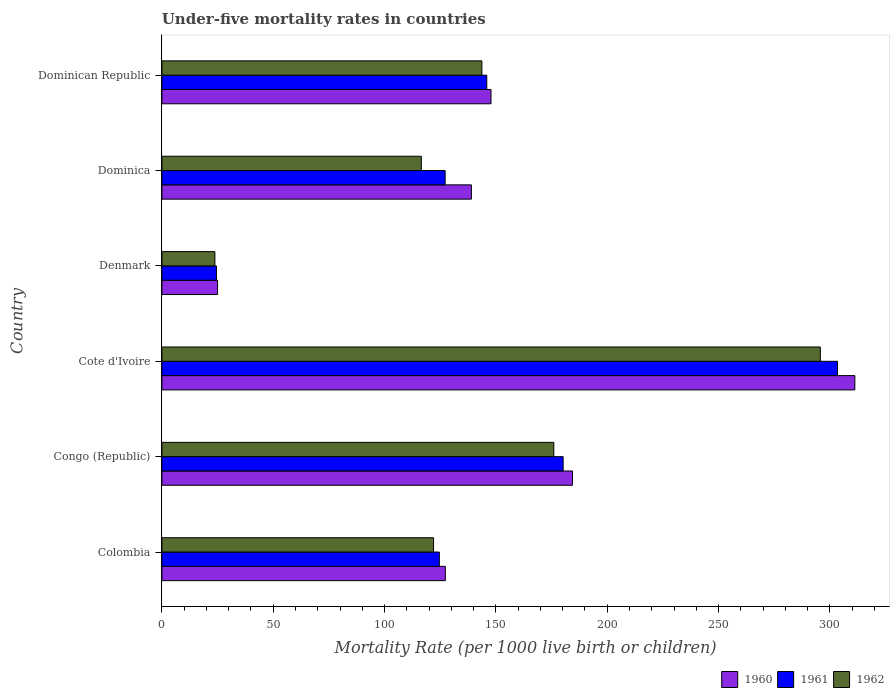How many groups of bars are there?
Your response must be concise. 6. Are the number of bars on each tick of the Y-axis equal?
Your answer should be very brief. Yes. How many bars are there on the 2nd tick from the top?
Offer a terse response. 3. How many bars are there on the 2nd tick from the bottom?
Offer a very short reply. 3. What is the label of the 1st group of bars from the top?
Provide a short and direct response. Dominican Republic. What is the under-five mortality rate in 1962 in Cote d'Ivoire?
Your answer should be very brief. 295.7. Across all countries, what is the maximum under-five mortality rate in 1961?
Give a very brief answer. 303.4. Across all countries, what is the minimum under-five mortality rate in 1960?
Your answer should be compact. 25. In which country was the under-five mortality rate in 1962 maximum?
Your response must be concise. Cote d'Ivoire. In which country was the under-five mortality rate in 1961 minimum?
Your response must be concise. Denmark. What is the total under-five mortality rate in 1962 in the graph?
Make the answer very short. 877.7. What is the difference between the under-five mortality rate in 1960 in Congo (Republic) and that in Dominican Republic?
Offer a very short reply. 36.6. What is the difference between the under-five mortality rate in 1961 in Denmark and the under-five mortality rate in 1960 in Cote d'Ivoire?
Your answer should be compact. -286.7. What is the average under-five mortality rate in 1962 per country?
Keep it short and to the point. 146.28. What is the difference between the under-five mortality rate in 1961 and under-five mortality rate in 1962 in Dominica?
Ensure brevity in your answer.  10.7. In how many countries, is the under-five mortality rate in 1961 greater than 150 ?
Your response must be concise. 2. What is the ratio of the under-five mortality rate in 1961 in Dominica to that in Dominican Republic?
Make the answer very short. 0.87. Is the difference between the under-five mortality rate in 1961 in Cote d'Ivoire and Denmark greater than the difference between the under-five mortality rate in 1962 in Cote d'Ivoire and Denmark?
Provide a succinct answer. Yes. What is the difference between the highest and the second highest under-five mortality rate in 1960?
Give a very brief answer. 126.8. What is the difference between the highest and the lowest under-five mortality rate in 1960?
Give a very brief answer. 286.2. Is the sum of the under-five mortality rate in 1962 in Colombia and Denmark greater than the maximum under-five mortality rate in 1961 across all countries?
Ensure brevity in your answer.  No. How many bars are there?
Give a very brief answer. 18. Are all the bars in the graph horizontal?
Provide a succinct answer. Yes. How many countries are there in the graph?
Your answer should be compact. 6. Does the graph contain any zero values?
Give a very brief answer. No. Does the graph contain grids?
Ensure brevity in your answer.  No. How are the legend labels stacked?
Your response must be concise. Horizontal. What is the title of the graph?
Your answer should be compact. Under-five mortality rates in countries. What is the label or title of the X-axis?
Ensure brevity in your answer.  Mortality Rate (per 1000 live birth or children). What is the Mortality Rate (per 1000 live birth or children) of 1960 in Colombia?
Your answer should be very brief. 127.3. What is the Mortality Rate (per 1000 live birth or children) of 1961 in Colombia?
Keep it short and to the point. 124.6. What is the Mortality Rate (per 1000 live birth or children) in 1962 in Colombia?
Give a very brief answer. 122. What is the Mortality Rate (per 1000 live birth or children) in 1960 in Congo (Republic)?
Your answer should be compact. 184.4. What is the Mortality Rate (per 1000 live birth or children) in 1961 in Congo (Republic)?
Make the answer very short. 180.2. What is the Mortality Rate (per 1000 live birth or children) in 1962 in Congo (Republic)?
Offer a very short reply. 176. What is the Mortality Rate (per 1000 live birth or children) of 1960 in Cote d'Ivoire?
Your answer should be compact. 311.2. What is the Mortality Rate (per 1000 live birth or children) in 1961 in Cote d'Ivoire?
Offer a terse response. 303.4. What is the Mortality Rate (per 1000 live birth or children) in 1962 in Cote d'Ivoire?
Your answer should be very brief. 295.7. What is the Mortality Rate (per 1000 live birth or children) in 1960 in Denmark?
Offer a very short reply. 25. What is the Mortality Rate (per 1000 live birth or children) of 1961 in Denmark?
Your response must be concise. 24.5. What is the Mortality Rate (per 1000 live birth or children) in 1962 in Denmark?
Provide a succinct answer. 23.8. What is the Mortality Rate (per 1000 live birth or children) in 1960 in Dominica?
Provide a succinct answer. 139. What is the Mortality Rate (per 1000 live birth or children) in 1961 in Dominica?
Provide a succinct answer. 127.2. What is the Mortality Rate (per 1000 live birth or children) of 1962 in Dominica?
Your answer should be very brief. 116.5. What is the Mortality Rate (per 1000 live birth or children) of 1960 in Dominican Republic?
Offer a very short reply. 147.8. What is the Mortality Rate (per 1000 live birth or children) of 1961 in Dominican Republic?
Ensure brevity in your answer.  145.9. What is the Mortality Rate (per 1000 live birth or children) of 1962 in Dominican Republic?
Provide a short and direct response. 143.7. Across all countries, what is the maximum Mortality Rate (per 1000 live birth or children) of 1960?
Your answer should be very brief. 311.2. Across all countries, what is the maximum Mortality Rate (per 1000 live birth or children) of 1961?
Ensure brevity in your answer.  303.4. Across all countries, what is the maximum Mortality Rate (per 1000 live birth or children) of 1962?
Your answer should be compact. 295.7. Across all countries, what is the minimum Mortality Rate (per 1000 live birth or children) in 1962?
Offer a terse response. 23.8. What is the total Mortality Rate (per 1000 live birth or children) of 1960 in the graph?
Make the answer very short. 934.7. What is the total Mortality Rate (per 1000 live birth or children) of 1961 in the graph?
Offer a terse response. 905.8. What is the total Mortality Rate (per 1000 live birth or children) in 1962 in the graph?
Make the answer very short. 877.7. What is the difference between the Mortality Rate (per 1000 live birth or children) in 1960 in Colombia and that in Congo (Republic)?
Keep it short and to the point. -57.1. What is the difference between the Mortality Rate (per 1000 live birth or children) in 1961 in Colombia and that in Congo (Republic)?
Make the answer very short. -55.6. What is the difference between the Mortality Rate (per 1000 live birth or children) of 1962 in Colombia and that in Congo (Republic)?
Offer a very short reply. -54. What is the difference between the Mortality Rate (per 1000 live birth or children) in 1960 in Colombia and that in Cote d'Ivoire?
Ensure brevity in your answer.  -183.9. What is the difference between the Mortality Rate (per 1000 live birth or children) in 1961 in Colombia and that in Cote d'Ivoire?
Provide a short and direct response. -178.8. What is the difference between the Mortality Rate (per 1000 live birth or children) of 1962 in Colombia and that in Cote d'Ivoire?
Your answer should be compact. -173.7. What is the difference between the Mortality Rate (per 1000 live birth or children) of 1960 in Colombia and that in Denmark?
Your answer should be very brief. 102.3. What is the difference between the Mortality Rate (per 1000 live birth or children) of 1961 in Colombia and that in Denmark?
Ensure brevity in your answer.  100.1. What is the difference between the Mortality Rate (per 1000 live birth or children) in 1962 in Colombia and that in Denmark?
Your answer should be compact. 98.2. What is the difference between the Mortality Rate (per 1000 live birth or children) in 1962 in Colombia and that in Dominica?
Keep it short and to the point. 5.5. What is the difference between the Mortality Rate (per 1000 live birth or children) in 1960 in Colombia and that in Dominican Republic?
Your answer should be compact. -20.5. What is the difference between the Mortality Rate (per 1000 live birth or children) of 1961 in Colombia and that in Dominican Republic?
Provide a short and direct response. -21.3. What is the difference between the Mortality Rate (per 1000 live birth or children) in 1962 in Colombia and that in Dominican Republic?
Your answer should be compact. -21.7. What is the difference between the Mortality Rate (per 1000 live birth or children) of 1960 in Congo (Republic) and that in Cote d'Ivoire?
Keep it short and to the point. -126.8. What is the difference between the Mortality Rate (per 1000 live birth or children) of 1961 in Congo (Republic) and that in Cote d'Ivoire?
Offer a very short reply. -123.2. What is the difference between the Mortality Rate (per 1000 live birth or children) in 1962 in Congo (Republic) and that in Cote d'Ivoire?
Offer a terse response. -119.7. What is the difference between the Mortality Rate (per 1000 live birth or children) of 1960 in Congo (Republic) and that in Denmark?
Your answer should be very brief. 159.4. What is the difference between the Mortality Rate (per 1000 live birth or children) of 1961 in Congo (Republic) and that in Denmark?
Keep it short and to the point. 155.7. What is the difference between the Mortality Rate (per 1000 live birth or children) of 1962 in Congo (Republic) and that in Denmark?
Make the answer very short. 152.2. What is the difference between the Mortality Rate (per 1000 live birth or children) in 1960 in Congo (Republic) and that in Dominica?
Your answer should be compact. 45.4. What is the difference between the Mortality Rate (per 1000 live birth or children) in 1961 in Congo (Republic) and that in Dominica?
Give a very brief answer. 53. What is the difference between the Mortality Rate (per 1000 live birth or children) in 1962 in Congo (Republic) and that in Dominica?
Your answer should be very brief. 59.5. What is the difference between the Mortality Rate (per 1000 live birth or children) in 1960 in Congo (Republic) and that in Dominican Republic?
Your answer should be very brief. 36.6. What is the difference between the Mortality Rate (per 1000 live birth or children) of 1961 in Congo (Republic) and that in Dominican Republic?
Keep it short and to the point. 34.3. What is the difference between the Mortality Rate (per 1000 live birth or children) in 1962 in Congo (Republic) and that in Dominican Republic?
Make the answer very short. 32.3. What is the difference between the Mortality Rate (per 1000 live birth or children) of 1960 in Cote d'Ivoire and that in Denmark?
Provide a succinct answer. 286.2. What is the difference between the Mortality Rate (per 1000 live birth or children) in 1961 in Cote d'Ivoire and that in Denmark?
Offer a terse response. 278.9. What is the difference between the Mortality Rate (per 1000 live birth or children) in 1962 in Cote d'Ivoire and that in Denmark?
Keep it short and to the point. 271.9. What is the difference between the Mortality Rate (per 1000 live birth or children) of 1960 in Cote d'Ivoire and that in Dominica?
Offer a very short reply. 172.2. What is the difference between the Mortality Rate (per 1000 live birth or children) in 1961 in Cote d'Ivoire and that in Dominica?
Give a very brief answer. 176.2. What is the difference between the Mortality Rate (per 1000 live birth or children) of 1962 in Cote d'Ivoire and that in Dominica?
Provide a short and direct response. 179.2. What is the difference between the Mortality Rate (per 1000 live birth or children) in 1960 in Cote d'Ivoire and that in Dominican Republic?
Offer a very short reply. 163.4. What is the difference between the Mortality Rate (per 1000 live birth or children) of 1961 in Cote d'Ivoire and that in Dominican Republic?
Your answer should be very brief. 157.5. What is the difference between the Mortality Rate (per 1000 live birth or children) of 1962 in Cote d'Ivoire and that in Dominican Republic?
Offer a terse response. 152. What is the difference between the Mortality Rate (per 1000 live birth or children) in 1960 in Denmark and that in Dominica?
Ensure brevity in your answer.  -114. What is the difference between the Mortality Rate (per 1000 live birth or children) in 1961 in Denmark and that in Dominica?
Ensure brevity in your answer.  -102.7. What is the difference between the Mortality Rate (per 1000 live birth or children) of 1962 in Denmark and that in Dominica?
Offer a terse response. -92.7. What is the difference between the Mortality Rate (per 1000 live birth or children) of 1960 in Denmark and that in Dominican Republic?
Offer a very short reply. -122.8. What is the difference between the Mortality Rate (per 1000 live birth or children) of 1961 in Denmark and that in Dominican Republic?
Keep it short and to the point. -121.4. What is the difference between the Mortality Rate (per 1000 live birth or children) of 1962 in Denmark and that in Dominican Republic?
Keep it short and to the point. -119.9. What is the difference between the Mortality Rate (per 1000 live birth or children) of 1961 in Dominica and that in Dominican Republic?
Give a very brief answer. -18.7. What is the difference between the Mortality Rate (per 1000 live birth or children) in 1962 in Dominica and that in Dominican Republic?
Your response must be concise. -27.2. What is the difference between the Mortality Rate (per 1000 live birth or children) of 1960 in Colombia and the Mortality Rate (per 1000 live birth or children) of 1961 in Congo (Republic)?
Make the answer very short. -52.9. What is the difference between the Mortality Rate (per 1000 live birth or children) of 1960 in Colombia and the Mortality Rate (per 1000 live birth or children) of 1962 in Congo (Republic)?
Make the answer very short. -48.7. What is the difference between the Mortality Rate (per 1000 live birth or children) of 1961 in Colombia and the Mortality Rate (per 1000 live birth or children) of 1962 in Congo (Republic)?
Provide a short and direct response. -51.4. What is the difference between the Mortality Rate (per 1000 live birth or children) in 1960 in Colombia and the Mortality Rate (per 1000 live birth or children) in 1961 in Cote d'Ivoire?
Keep it short and to the point. -176.1. What is the difference between the Mortality Rate (per 1000 live birth or children) in 1960 in Colombia and the Mortality Rate (per 1000 live birth or children) in 1962 in Cote d'Ivoire?
Provide a succinct answer. -168.4. What is the difference between the Mortality Rate (per 1000 live birth or children) in 1961 in Colombia and the Mortality Rate (per 1000 live birth or children) in 1962 in Cote d'Ivoire?
Make the answer very short. -171.1. What is the difference between the Mortality Rate (per 1000 live birth or children) of 1960 in Colombia and the Mortality Rate (per 1000 live birth or children) of 1961 in Denmark?
Ensure brevity in your answer.  102.8. What is the difference between the Mortality Rate (per 1000 live birth or children) in 1960 in Colombia and the Mortality Rate (per 1000 live birth or children) in 1962 in Denmark?
Keep it short and to the point. 103.5. What is the difference between the Mortality Rate (per 1000 live birth or children) of 1961 in Colombia and the Mortality Rate (per 1000 live birth or children) of 1962 in Denmark?
Offer a terse response. 100.8. What is the difference between the Mortality Rate (per 1000 live birth or children) in 1960 in Colombia and the Mortality Rate (per 1000 live birth or children) in 1961 in Dominica?
Ensure brevity in your answer.  0.1. What is the difference between the Mortality Rate (per 1000 live birth or children) of 1960 in Colombia and the Mortality Rate (per 1000 live birth or children) of 1962 in Dominica?
Make the answer very short. 10.8. What is the difference between the Mortality Rate (per 1000 live birth or children) of 1960 in Colombia and the Mortality Rate (per 1000 live birth or children) of 1961 in Dominican Republic?
Give a very brief answer. -18.6. What is the difference between the Mortality Rate (per 1000 live birth or children) of 1960 in Colombia and the Mortality Rate (per 1000 live birth or children) of 1962 in Dominican Republic?
Give a very brief answer. -16.4. What is the difference between the Mortality Rate (per 1000 live birth or children) in 1961 in Colombia and the Mortality Rate (per 1000 live birth or children) in 1962 in Dominican Republic?
Make the answer very short. -19.1. What is the difference between the Mortality Rate (per 1000 live birth or children) in 1960 in Congo (Republic) and the Mortality Rate (per 1000 live birth or children) in 1961 in Cote d'Ivoire?
Your response must be concise. -119. What is the difference between the Mortality Rate (per 1000 live birth or children) of 1960 in Congo (Republic) and the Mortality Rate (per 1000 live birth or children) of 1962 in Cote d'Ivoire?
Give a very brief answer. -111.3. What is the difference between the Mortality Rate (per 1000 live birth or children) in 1961 in Congo (Republic) and the Mortality Rate (per 1000 live birth or children) in 1962 in Cote d'Ivoire?
Give a very brief answer. -115.5. What is the difference between the Mortality Rate (per 1000 live birth or children) in 1960 in Congo (Republic) and the Mortality Rate (per 1000 live birth or children) in 1961 in Denmark?
Your response must be concise. 159.9. What is the difference between the Mortality Rate (per 1000 live birth or children) in 1960 in Congo (Republic) and the Mortality Rate (per 1000 live birth or children) in 1962 in Denmark?
Your answer should be compact. 160.6. What is the difference between the Mortality Rate (per 1000 live birth or children) of 1961 in Congo (Republic) and the Mortality Rate (per 1000 live birth or children) of 1962 in Denmark?
Provide a succinct answer. 156.4. What is the difference between the Mortality Rate (per 1000 live birth or children) of 1960 in Congo (Republic) and the Mortality Rate (per 1000 live birth or children) of 1961 in Dominica?
Your response must be concise. 57.2. What is the difference between the Mortality Rate (per 1000 live birth or children) in 1960 in Congo (Republic) and the Mortality Rate (per 1000 live birth or children) in 1962 in Dominica?
Keep it short and to the point. 67.9. What is the difference between the Mortality Rate (per 1000 live birth or children) of 1961 in Congo (Republic) and the Mortality Rate (per 1000 live birth or children) of 1962 in Dominica?
Your answer should be compact. 63.7. What is the difference between the Mortality Rate (per 1000 live birth or children) of 1960 in Congo (Republic) and the Mortality Rate (per 1000 live birth or children) of 1961 in Dominican Republic?
Your answer should be compact. 38.5. What is the difference between the Mortality Rate (per 1000 live birth or children) in 1960 in Congo (Republic) and the Mortality Rate (per 1000 live birth or children) in 1962 in Dominican Republic?
Provide a succinct answer. 40.7. What is the difference between the Mortality Rate (per 1000 live birth or children) in 1961 in Congo (Republic) and the Mortality Rate (per 1000 live birth or children) in 1962 in Dominican Republic?
Offer a terse response. 36.5. What is the difference between the Mortality Rate (per 1000 live birth or children) in 1960 in Cote d'Ivoire and the Mortality Rate (per 1000 live birth or children) in 1961 in Denmark?
Provide a succinct answer. 286.7. What is the difference between the Mortality Rate (per 1000 live birth or children) of 1960 in Cote d'Ivoire and the Mortality Rate (per 1000 live birth or children) of 1962 in Denmark?
Your answer should be very brief. 287.4. What is the difference between the Mortality Rate (per 1000 live birth or children) in 1961 in Cote d'Ivoire and the Mortality Rate (per 1000 live birth or children) in 1962 in Denmark?
Your answer should be compact. 279.6. What is the difference between the Mortality Rate (per 1000 live birth or children) of 1960 in Cote d'Ivoire and the Mortality Rate (per 1000 live birth or children) of 1961 in Dominica?
Make the answer very short. 184. What is the difference between the Mortality Rate (per 1000 live birth or children) of 1960 in Cote d'Ivoire and the Mortality Rate (per 1000 live birth or children) of 1962 in Dominica?
Offer a very short reply. 194.7. What is the difference between the Mortality Rate (per 1000 live birth or children) of 1961 in Cote d'Ivoire and the Mortality Rate (per 1000 live birth or children) of 1962 in Dominica?
Make the answer very short. 186.9. What is the difference between the Mortality Rate (per 1000 live birth or children) in 1960 in Cote d'Ivoire and the Mortality Rate (per 1000 live birth or children) in 1961 in Dominican Republic?
Offer a very short reply. 165.3. What is the difference between the Mortality Rate (per 1000 live birth or children) of 1960 in Cote d'Ivoire and the Mortality Rate (per 1000 live birth or children) of 1962 in Dominican Republic?
Keep it short and to the point. 167.5. What is the difference between the Mortality Rate (per 1000 live birth or children) in 1961 in Cote d'Ivoire and the Mortality Rate (per 1000 live birth or children) in 1962 in Dominican Republic?
Make the answer very short. 159.7. What is the difference between the Mortality Rate (per 1000 live birth or children) of 1960 in Denmark and the Mortality Rate (per 1000 live birth or children) of 1961 in Dominica?
Offer a terse response. -102.2. What is the difference between the Mortality Rate (per 1000 live birth or children) of 1960 in Denmark and the Mortality Rate (per 1000 live birth or children) of 1962 in Dominica?
Your response must be concise. -91.5. What is the difference between the Mortality Rate (per 1000 live birth or children) in 1961 in Denmark and the Mortality Rate (per 1000 live birth or children) in 1962 in Dominica?
Offer a very short reply. -92. What is the difference between the Mortality Rate (per 1000 live birth or children) in 1960 in Denmark and the Mortality Rate (per 1000 live birth or children) in 1961 in Dominican Republic?
Your answer should be very brief. -120.9. What is the difference between the Mortality Rate (per 1000 live birth or children) in 1960 in Denmark and the Mortality Rate (per 1000 live birth or children) in 1962 in Dominican Republic?
Give a very brief answer. -118.7. What is the difference between the Mortality Rate (per 1000 live birth or children) in 1961 in Denmark and the Mortality Rate (per 1000 live birth or children) in 1962 in Dominican Republic?
Offer a very short reply. -119.2. What is the difference between the Mortality Rate (per 1000 live birth or children) of 1960 in Dominica and the Mortality Rate (per 1000 live birth or children) of 1962 in Dominican Republic?
Provide a short and direct response. -4.7. What is the difference between the Mortality Rate (per 1000 live birth or children) of 1961 in Dominica and the Mortality Rate (per 1000 live birth or children) of 1962 in Dominican Republic?
Ensure brevity in your answer.  -16.5. What is the average Mortality Rate (per 1000 live birth or children) of 1960 per country?
Offer a very short reply. 155.78. What is the average Mortality Rate (per 1000 live birth or children) of 1961 per country?
Your answer should be very brief. 150.97. What is the average Mortality Rate (per 1000 live birth or children) in 1962 per country?
Offer a terse response. 146.28. What is the difference between the Mortality Rate (per 1000 live birth or children) of 1960 and Mortality Rate (per 1000 live birth or children) of 1962 in Colombia?
Offer a very short reply. 5.3. What is the difference between the Mortality Rate (per 1000 live birth or children) of 1960 and Mortality Rate (per 1000 live birth or children) of 1961 in Congo (Republic)?
Provide a succinct answer. 4.2. What is the difference between the Mortality Rate (per 1000 live birth or children) of 1961 and Mortality Rate (per 1000 live birth or children) of 1962 in Congo (Republic)?
Give a very brief answer. 4.2. What is the difference between the Mortality Rate (per 1000 live birth or children) of 1961 and Mortality Rate (per 1000 live birth or children) of 1962 in Cote d'Ivoire?
Your answer should be very brief. 7.7. What is the difference between the Mortality Rate (per 1000 live birth or children) of 1960 and Mortality Rate (per 1000 live birth or children) of 1962 in Denmark?
Your response must be concise. 1.2. What is the difference between the Mortality Rate (per 1000 live birth or children) in 1960 and Mortality Rate (per 1000 live birth or children) in 1961 in Dominica?
Offer a very short reply. 11.8. What is the difference between the Mortality Rate (per 1000 live birth or children) in 1960 and Mortality Rate (per 1000 live birth or children) in 1962 in Dominica?
Offer a terse response. 22.5. What is the difference between the Mortality Rate (per 1000 live birth or children) in 1961 and Mortality Rate (per 1000 live birth or children) in 1962 in Dominica?
Give a very brief answer. 10.7. What is the difference between the Mortality Rate (per 1000 live birth or children) in 1961 and Mortality Rate (per 1000 live birth or children) in 1962 in Dominican Republic?
Offer a very short reply. 2.2. What is the ratio of the Mortality Rate (per 1000 live birth or children) in 1960 in Colombia to that in Congo (Republic)?
Keep it short and to the point. 0.69. What is the ratio of the Mortality Rate (per 1000 live birth or children) of 1961 in Colombia to that in Congo (Republic)?
Offer a very short reply. 0.69. What is the ratio of the Mortality Rate (per 1000 live birth or children) in 1962 in Colombia to that in Congo (Republic)?
Provide a short and direct response. 0.69. What is the ratio of the Mortality Rate (per 1000 live birth or children) in 1960 in Colombia to that in Cote d'Ivoire?
Make the answer very short. 0.41. What is the ratio of the Mortality Rate (per 1000 live birth or children) of 1961 in Colombia to that in Cote d'Ivoire?
Give a very brief answer. 0.41. What is the ratio of the Mortality Rate (per 1000 live birth or children) in 1962 in Colombia to that in Cote d'Ivoire?
Offer a very short reply. 0.41. What is the ratio of the Mortality Rate (per 1000 live birth or children) of 1960 in Colombia to that in Denmark?
Ensure brevity in your answer.  5.09. What is the ratio of the Mortality Rate (per 1000 live birth or children) of 1961 in Colombia to that in Denmark?
Ensure brevity in your answer.  5.09. What is the ratio of the Mortality Rate (per 1000 live birth or children) in 1962 in Colombia to that in Denmark?
Keep it short and to the point. 5.13. What is the ratio of the Mortality Rate (per 1000 live birth or children) in 1960 in Colombia to that in Dominica?
Your answer should be very brief. 0.92. What is the ratio of the Mortality Rate (per 1000 live birth or children) in 1961 in Colombia to that in Dominica?
Make the answer very short. 0.98. What is the ratio of the Mortality Rate (per 1000 live birth or children) of 1962 in Colombia to that in Dominica?
Offer a terse response. 1.05. What is the ratio of the Mortality Rate (per 1000 live birth or children) of 1960 in Colombia to that in Dominican Republic?
Offer a very short reply. 0.86. What is the ratio of the Mortality Rate (per 1000 live birth or children) of 1961 in Colombia to that in Dominican Republic?
Your response must be concise. 0.85. What is the ratio of the Mortality Rate (per 1000 live birth or children) of 1962 in Colombia to that in Dominican Republic?
Your response must be concise. 0.85. What is the ratio of the Mortality Rate (per 1000 live birth or children) of 1960 in Congo (Republic) to that in Cote d'Ivoire?
Your response must be concise. 0.59. What is the ratio of the Mortality Rate (per 1000 live birth or children) in 1961 in Congo (Republic) to that in Cote d'Ivoire?
Ensure brevity in your answer.  0.59. What is the ratio of the Mortality Rate (per 1000 live birth or children) in 1962 in Congo (Republic) to that in Cote d'Ivoire?
Make the answer very short. 0.6. What is the ratio of the Mortality Rate (per 1000 live birth or children) in 1960 in Congo (Republic) to that in Denmark?
Offer a terse response. 7.38. What is the ratio of the Mortality Rate (per 1000 live birth or children) of 1961 in Congo (Republic) to that in Denmark?
Provide a short and direct response. 7.36. What is the ratio of the Mortality Rate (per 1000 live birth or children) in 1962 in Congo (Republic) to that in Denmark?
Keep it short and to the point. 7.39. What is the ratio of the Mortality Rate (per 1000 live birth or children) in 1960 in Congo (Republic) to that in Dominica?
Make the answer very short. 1.33. What is the ratio of the Mortality Rate (per 1000 live birth or children) in 1961 in Congo (Republic) to that in Dominica?
Offer a terse response. 1.42. What is the ratio of the Mortality Rate (per 1000 live birth or children) of 1962 in Congo (Republic) to that in Dominica?
Your answer should be very brief. 1.51. What is the ratio of the Mortality Rate (per 1000 live birth or children) in 1960 in Congo (Republic) to that in Dominican Republic?
Provide a succinct answer. 1.25. What is the ratio of the Mortality Rate (per 1000 live birth or children) of 1961 in Congo (Republic) to that in Dominican Republic?
Offer a terse response. 1.24. What is the ratio of the Mortality Rate (per 1000 live birth or children) of 1962 in Congo (Republic) to that in Dominican Republic?
Provide a short and direct response. 1.22. What is the ratio of the Mortality Rate (per 1000 live birth or children) in 1960 in Cote d'Ivoire to that in Denmark?
Give a very brief answer. 12.45. What is the ratio of the Mortality Rate (per 1000 live birth or children) in 1961 in Cote d'Ivoire to that in Denmark?
Offer a very short reply. 12.38. What is the ratio of the Mortality Rate (per 1000 live birth or children) in 1962 in Cote d'Ivoire to that in Denmark?
Provide a short and direct response. 12.42. What is the ratio of the Mortality Rate (per 1000 live birth or children) of 1960 in Cote d'Ivoire to that in Dominica?
Make the answer very short. 2.24. What is the ratio of the Mortality Rate (per 1000 live birth or children) in 1961 in Cote d'Ivoire to that in Dominica?
Make the answer very short. 2.39. What is the ratio of the Mortality Rate (per 1000 live birth or children) of 1962 in Cote d'Ivoire to that in Dominica?
Ensure brevity in your answer.  2.54. What is the ratio of the Mortality Rate (per 1000 live birth or children) of 1960 in Cote d'Ivoire to that in Dominican Republic?
Your answer should be compact. 2.11. What is the ratio of the Mortality Rate (per 1000 live birth or children) of 1961 in Cote d'Ivoire to that in Dominican Republic?
Your answer should be very brief. 2.08. What is the ratio of the Mortality Rate (per 1000 live birth or children) of 1962 in Cote d'Ivoire to that in Dominican Republic?
Keep it short and to the point. 2.06. What is the ratio of the Mortality Rate (per 1000 live birth or children) in 1960 in Denmark to that in Dominica?
Offer a very short reply. 0.18. What is the ratio of the Mortality Rate (per 1000 live birth or children) in 1961 in Denmark to that in Dominica?
Offer a terse response. 0.19. What is the ratio of the Mortality Rate (per 1000 live birth or children) of 1962 in Denmark to that in Dominica?
Ensure brevity in your answer.  0.2. What is the ratio of the Mortality Rate (per 1000 live birth or children) of 1960 in Denmark to that in Dominican Republic?
Provide a succinct answer. 0.17. What is the ratio of the Mortality Rate (per 1000 live birth or children) in 1961 in Denmark to that in Dominican Republic?
Provide a succinct answer. 0.17. What is the ratio of the Mortality Rate (per 1000 live birth or children) of 1962 in Denmark to that in Dominican Republic?
Provide a succinct answer. 0.17. What is the ratio of the Mortality Rate (per 1000 live birth or children) in 1960 in Dominica to that in Dominican Republic?
Ensure brevity in your answer.  0.94. What is the ratio of the Mortality Rate (per 1000 live birth or children) of 1961 in Dominica to that in Dominican Republic?
Provide a short and direct response. 0.87. What is the ratio of the Mortality Rate (per 1000 live birth or children) of 1962 in Dominica to that in Dominican Republic?
Keep it short and to the point. 0.81. What is the difference between the highest and the second highest Mortality Rate (per 1000 live birth or children) of 1960?
Offer a terse response. 126.8. What is the difference between the highest and the second highest Mortality Rate (per 1000 live birth or children) of 1961?
Your answer should be compact. 123.2. What is the difference between the highest and the second highest Mortality Rate (per 1000 live birth or children) in 1962?
Ensure brevity in your answer.  119.7. What is the difference between the highest and the lowest Mortality Rate (per 1000 live birth or children) in 1960?
Your answer should be very brief. 286.2. What is the difference between the highest and the lowest Mortality Rate (per 1000 live birth or children) in 1961?
Provide a succinct answer. 278.9. What is the difference between the highest and the lowest Mortality Rate (per 1000 live birth or children) of 1962?
Provide a short and direct response. 271.9. 